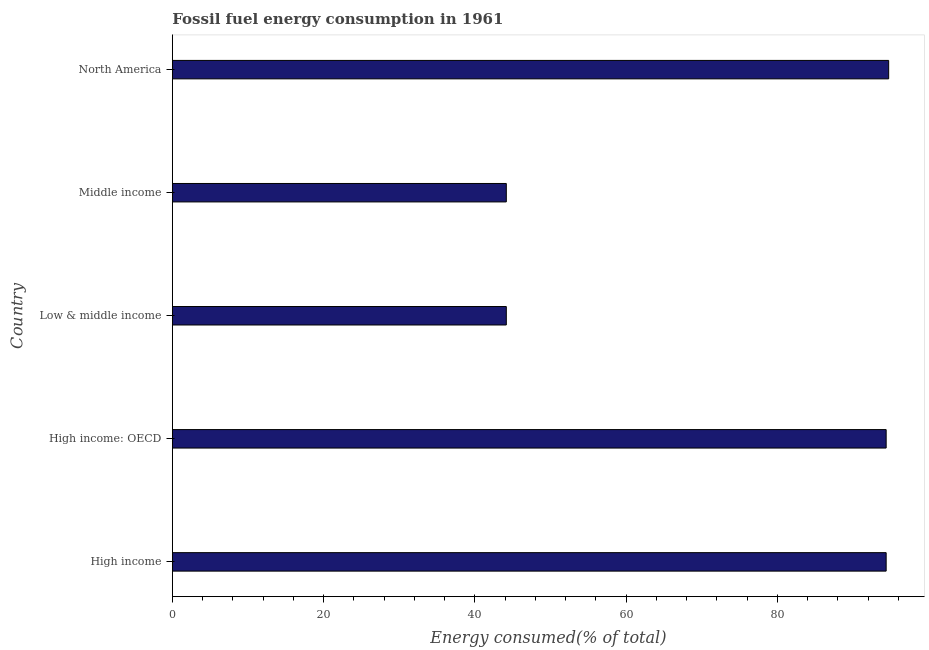Does the graph contain any zero values?
Make the answer very short. No. What is the title of the graph?
Offer a terse response. Fossil fuel energy consumption in 1961. What is the label or title of the X-axis?
Your answer should be compact. Energy consumed(% of total). What is the fossil fuel energy consumption in Low & middle income?
Provide a short and direct response. 44.16. Across all countries, what is the maximum fossil fuel energy consumption?
Your response must be concise. 94.72. Across all countries, what is the minimum fossil fuel energy consumption?
Your response must be concise. 44.16. What is the sum of the fossil fuel energy consumption?
Provide a succinct answer. 371.82. What is the difference between the fossil fuel energy consumption in Low & middle income and North America?
Your answer should be compact. -50.56. What is the average fossil fuel energy consumption per country?
Your answer should be very brief. 74.36. What is the median fossil fuel energy consumption?
Make the answer very short. 94.39. In how many countries, is the fossil fuel energy consumption greater than 40 %?
Your answer should be very brief. 5. What is the ratio of the fossil fuel energy consumption in Middle income to that in North America?
Your answer should be compact. 0.47. Is the difference between the fossil fuel energy consumption in Low & middle income and North America greater than the difference between any two countries?
Give a very brief answer. Yes. What is the difference between the highest and the second highest fossil fuel energy consumption?
Offer a very short reply. 0.33. What is the difference between the highest and the lowest fossil fuel energy consumption?
Your answer should be compact. 50.56. How many bars are there?
Give a very brief answer. 5. Are all the bars in the graph horizontal?
Offer a very short reply. Yes. What is the Energy consumed(% of total) in High income?
Offer a terse response. 94.39. What is the Energy consumed(% of total) in High income: OECD?
Offer a terse response. 94.39. What is the Energy consumed(% of total) in Low & middle income?
Provide a succinct answer. 44.16. What is the Energy consumed(% of total) of Middle income?
Provide a succinct answer. 44.16. What is the Energy consumed(% of total) in North America?
Your response must be concise. 94.72. What is the difference between the Energy consumed(% of total) in High income and High income: OECD?
Make the answer very short. 0. What is the difference between the Energy consumed(% of total) in High income and Low & middle income?
Your answer should be compact. 50.23. What is the difference between the Energy consumed(% of total) in High income and Middle income?
Provide a succinct answer. 50.23. What is the difference between the Energy consumed(% of total) in High income and North America?
Offer a terse response. -0.33. What is the difference between the Energy consumed(% of total) in High income: OECD and Low & middle income?
Ensure brevity in your answer.  50.23. What is the difference between the Energy consumed(% of total) in High income: OECD and Middle income?
Ensure brevity in your answer.  50.23. What is the difference between the Energy consumed(% of total) in High income: OECD and North America?
Your answer should be compact. -0.33. What is the difference between the Energy consumed(% of total) in Low & middle income and Middle income?
Your answer should be very brief. 0. What is the difference between the Energy consumed(% of total) in Low & middle income and North America?
Ensure brevity in your answer.  -50.56. What is the difference between the Energy consumed(% of total) in Middle income and North America?
Provide a succinct answer. -50.56. What is the ratio of the Energy consumed(% of total) in High income to that in High income: OECD?
Keep it short and to the point. 1. What is the ratio of the Energy consumed(% of total) in High income to that in Low & middle income?
Your response must be concise. 2.14. What is the ratio of the Energy consumed(% of total) in High income to that in Middle income?
Offer a very short reply. 2.14. What is the ratio of the Energy consumed(% of total) in High income: OECD to that in Low & middle income?
Your response must be concise. 2.14. What is the ratio of the Energy consumed(% of total) in High income: OECD to that in Middle income?
Your response must be concise. 2.14. What is the ratio of the Energy consumed(% of total) in Low & middle income to that in North America?
Provide a succinct answer. 0.47. What is the ratio of the Energy consumed(% of total) in Middle income to that in North America?
Your response must be concise. 0.47. 